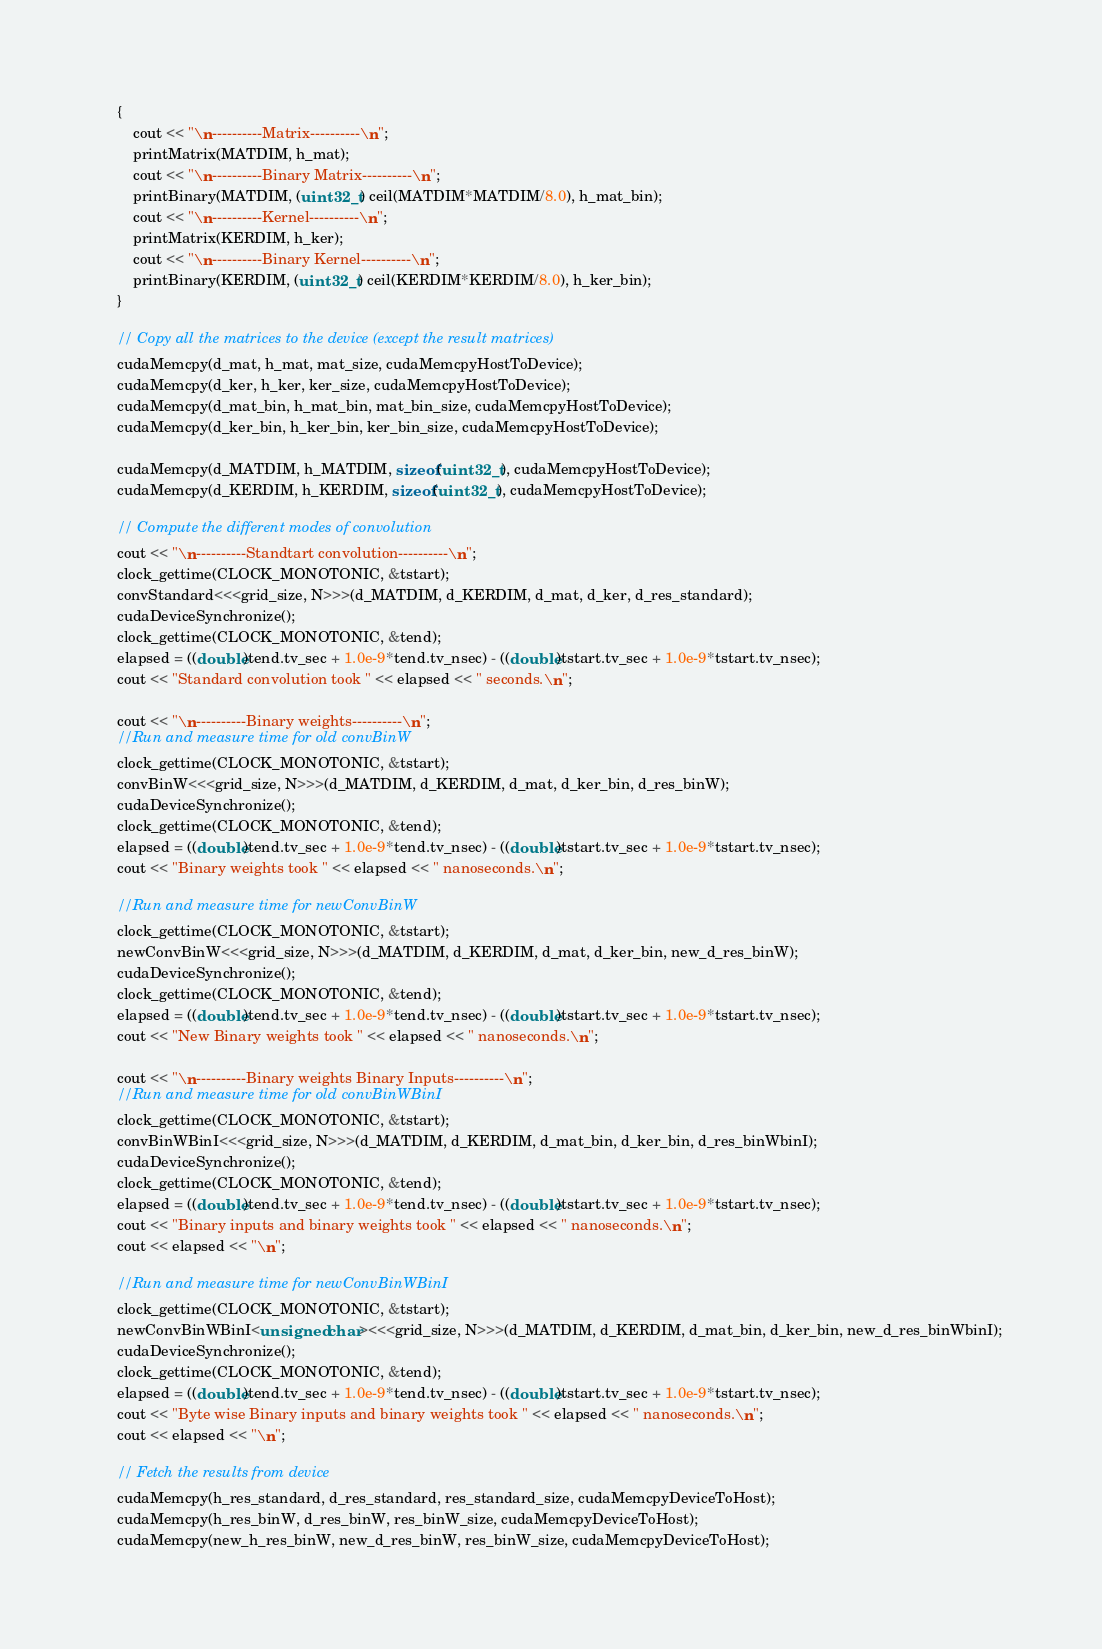<code> <loc_0><loc_0><loc_500><loc_500><_Cuda_>	{
		cout << "\n----------Matrix----------\n";
		printMatrix(MATDIM, h_mat);
		cout << "\n----------Binary Matrix----------\n";
		printBinary(MATDIM, (uint32_t) ceil(MATDIM*MATDIM/8.0), h_mat_bin);
		cout << "\n----------Kernel----------\n";
		printMatrix(KERDIM, h_ker);
		cout << "\n----------Binary Kernel----------\n";
		printBinary(KERDIM, (uint32_t) ceil(KERDIM*KERDIM/8.0), h_ker_bin);
	}

	// Copy all the matrices to the device (except the result matrices)
	cudaMemcpy(d_mat, h_mat, mat_size, cudaMemcpyHostToDevice);
	cudaMemcpy(d_ker, h_ker, ker_size, cudaMemcpyHostToDevice);
	cudaMemcpy(d_mat_bin, h_mat_bin, mat_bin_size, cudaMemcpyHostToDevice);
	cudaMemcpy(d_ker_bin, h_ker_bin, ker_bin_size, cudaMemcpyHostToDevice);

	cudaMemcpy(d_MATDIM, h_MATDIM, sizeof(uint32_t), cudaMemcpyHostToDevice);
	cudaMemcpy(d_KERDIM, h_KERDIM, sizeof(uint32_t), cudaMemcpyHostToDevice);

	// Compute the different modes of convolution
	cout << "\n----------Standtart convolution----------\n";
	clock_gettime(CLOCK_MONOTONIC, &tstart);
	convStandard<<<grid_size, N>>>(d_MATDIM, d_KERDIM, d_mat, d_ker, d_res_standard);
	cudaDeviceSynchronize();
	clock_gettime(CLOCK_MONOTONIC, &tend);
	elapsed = ((double)tend.tv_sec + 1.0e-9*tend.tv_nsec) - ((double)tstart.tv_sec + 1.0e-9*tstart.tv_nsec);
	cout << "Standard convolution took " << elapsed << " seconds.\n";

	cout << "\n----------Binary weights----------\n";
	//Run and measure time for old convBinW
	clock_gettime(CLOCK_MONOTONIC, &tstart);
	convBinW<<<grid_size, N>>>(d_MATDIM, d_KERDIM, d_mat, d_ker_bin, d_res_binW);
	cudaDeviceSynchronize();
	clock_gettime(CLOCK_MONOTONIC, &tend);
	elapsed = ((double)tend.tv_sec + 1.0e-9*tend.tv_nsec) - ((double)tstart.tv_sec + 1.0e-9*tstart.tv_nsec);
	cout << "Binary weights took " << elapsed << " nanoseconds.\n";

	//Run and measure time for newConvBinW
	clock_gettime(CLOCK_MONOTONIC, &tstart);
	newConvBinW<<<grid_size, N>>>(d_MATDIM, d_KERDIM, d_mat, d_ker_bin, new_d_res_binW);
	cudaDeviceSynchronize();
	clock_gettime(CLOCK_MONOTONIC, &tend);
	elapsed = ((double)tend.tv_sec + 1.0e-9*tend.tv_nsec) - ((double)tstart.tv_sec + 1.0e-9*tstart.tv_nsec);
	cout << "New Binary weights took " << elapsed << " nanoseconds.\n";

	cout << "\n----------Binary weights Binary Inputs----------\n";
	//Run and measure time for old convBinWBinI
	clock_gettime(CLOCK_MONOTONIC, &tstart);
	convBinWBinI<<<grid_size, N>>>(d_MATDIM, d_KERDIM, d_mat_bin, d_ker_bin, d_res_binWbinI);
	cudaDeviceSynchronize();
	clock_gettime(CLOCK_MONOTONIC, &tend);
	elapsed = ((double)tend.tv_sec + 1.0e-9*tend.tv_nsec) - ((double)tstart.tv_sec + 1.0e-9*tstart.tv_nsec);
	cout << "Binary inputs and binary weights took " << elapsed << " nanoseconds.\n";
	cout << elapsed << "\n";

	//Run and measure time for newConvBinWBinI
	clock_gettime(CLOCK_MONOTONIC, &tstart);
	newConvBinWBinI<unsigned char><<<grid_size, N>>>(d_MATDIM, d_KERDIM, d_mat_bin, d_ker_bin, new_d_res_binWbinI);
	cudaDeviceSynchronize();
	clock_gettime(CLOCK_MONOTONIC, &tend);
	elapsed = ((double)tend.tv_sec + 1.0e-9*tend.tv_nsec) - ((double)tstart.tv_sec + 1.0e-9*tstart.tv_nsec);
	cout << "Byte wise Binary inputs and binary weights took " << elapsed << " nanoseconds.\n";
	cout << elapsed << "\n";

	// Fetch the results from device
	cudaMemcpy(h_res_standard, d_res_standard, res_standard_size, cudaMemcpyDeviceToHost);
	cudaMemcpy(h_res_binW, d_res_binW, res_binW_size, cudaMemcpyDeviceToHost);
	cudaMemcpy(new_h_res_binW, new_d_res_binW, res_binW_size, cudaMemcpyDeviceToHost);</code> 